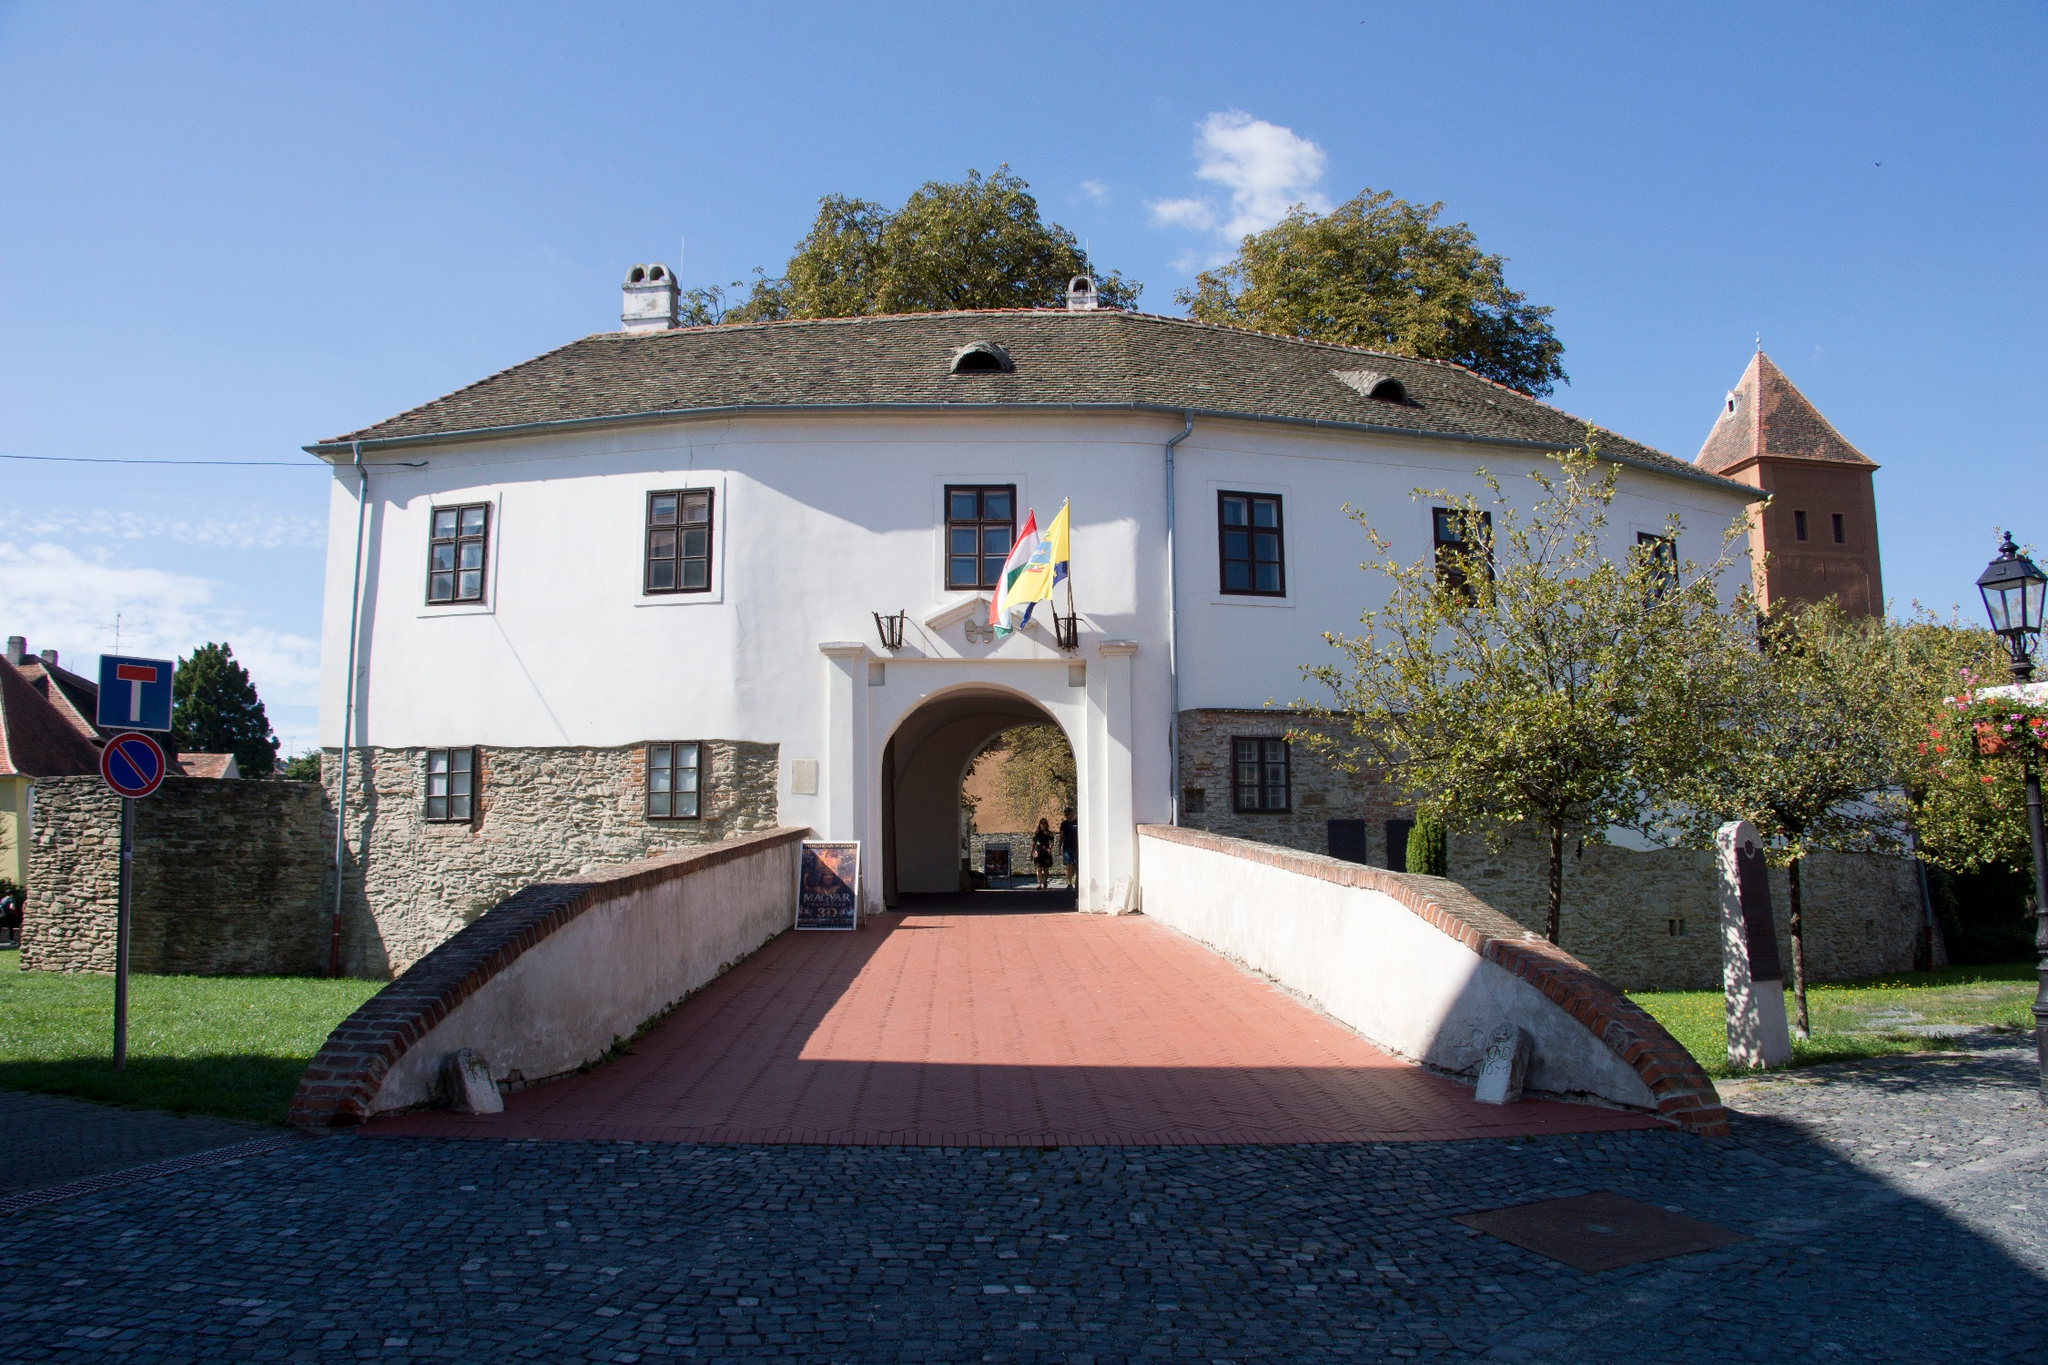Imagine this image as a setting for a historical novel. What could be the plot? In a historical novel set against the backdrop of the Prejmer fortified church, a young knight named Aric, newly inducted into the Teutonic Order, becomes embroiled in a web of intrigue and betrayal. The church, once a sanctuary, has turned into a hotbed of political maneuvering as various factions vie for control of the region. Aric, initially seeking only to prove his valor, finds himself uncovering dark secrets within the church's stone walls—secrets that could tip the balance of power. With the help of Elena, a local healer with knowledge of ancient lore, Aric must navigate perilous alliances and unearth the true heritage of the fortified church to protect the innocents caught in the crossfire. Can you provide a detailed description of a key scene from this novel? As the sun dipped below the horizon, the evening shadows cast long, twisting forms across the fortified church's courtyard. Aric, clad in a chainmail tunic, approached the heavy wooden doors, feeling the weight of his mission pressing down on his shoulders. The scent of damp earth mingled with the faint, lingering aroma of evening blooms as he pushed the door open. Inside, the air was cooler, filled with the hushed whispers of an ancient past. Flickering torches cast sporadic light upon the stone walls, revealing the intricate carvings and symbols etched into them by hands long gone. In a secluded alcove, Elena poured over an ancient manuscript, her brow furrowed in concentration. The faint scratch of quill on parchment was the only sound until Aric's footsteps echoed softly. 'We don't have much time,' she whispered urgently, not looking up. 'The emissaries will arrive at dawn.' Together, they decoded the cryptic message left by a long-deceased monk, a message that held the key to thwarting the plot against the church. As they worked, the sense of urgency heightened, each sound in the silent church amplified in their ears. They knew dawn would bring more than just a new day; it would bring a reckoning. What might this place have looked like during a festival in the medieval period? During a medieval festival, the Prejmer fortified church would have been a hub of vibrant activity and color. Flanking the robust, white-stone facade, banners and flags in vivid hues fluttered in the breeze, marking the festive occasion. Stalls adorned with garlands and streamers lined the red-brick walkway, offering an array of goods—from handwoven fabrics and intricate jewelry to an assortment of local delicacies and spiced wines. The air would be thick with the mingling fragrances of roasted meats, freshly baked bread, and seasonal fruits. Minstrels and performers, dressed in brightly colored costumes, entertained the crowds with music, dance, and acrobatics, their lively tunes echoing off the stone walls. The stone courtyard, usually a place of quiet reverence, now thrummed with the joyous chatter and laughter of townsfolk and visitors, their faces illuminated by the soft glow of lanterns as dusk fell. The festival not only showcased the cultural richness of the period but also reinforced communal bonds, transforming the fortified church into a scene of medieval revelry and camaraderie. What would an everyday scene be like in front of this church? An everyday scene in front of the Prejmer fortified church would likely be one of peaceful activity. In the early morning light, villagers would start their day, some tending to their market stalls set up along the red-brick walkway. Merchants would greet early buyers, offering fresh produce, baked goods, and handcrafted items. Local children might be seen playing on the lush green lawns, their laughter filling the air. As the day progresses, visitors and townsfolk alike might wander through, admiring the robust architecture of the church, with its white walls and red roof. The occasional sound of the church bell would punctuate the daily rhythm, calling the faithful to prayer or marking the time. A soft breeze would rustle the leaves of the trees, and the distant clinking of a blacksmith's hammer or the low hum of conversation would create a tranquil, community-focused atmosphere. 